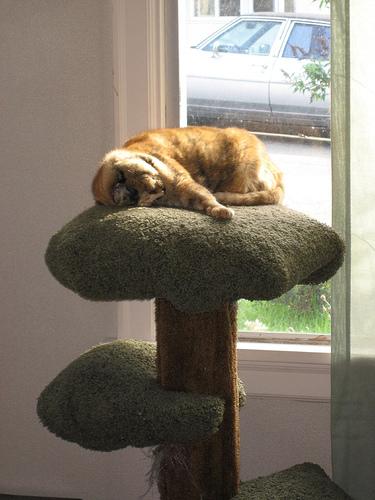What texture does the cat post have?
Give a very brief answer. Rough. Why is the post so high?
Answer briefly. To see out window. Who is the cat's owner?
Short answer required. Me. 